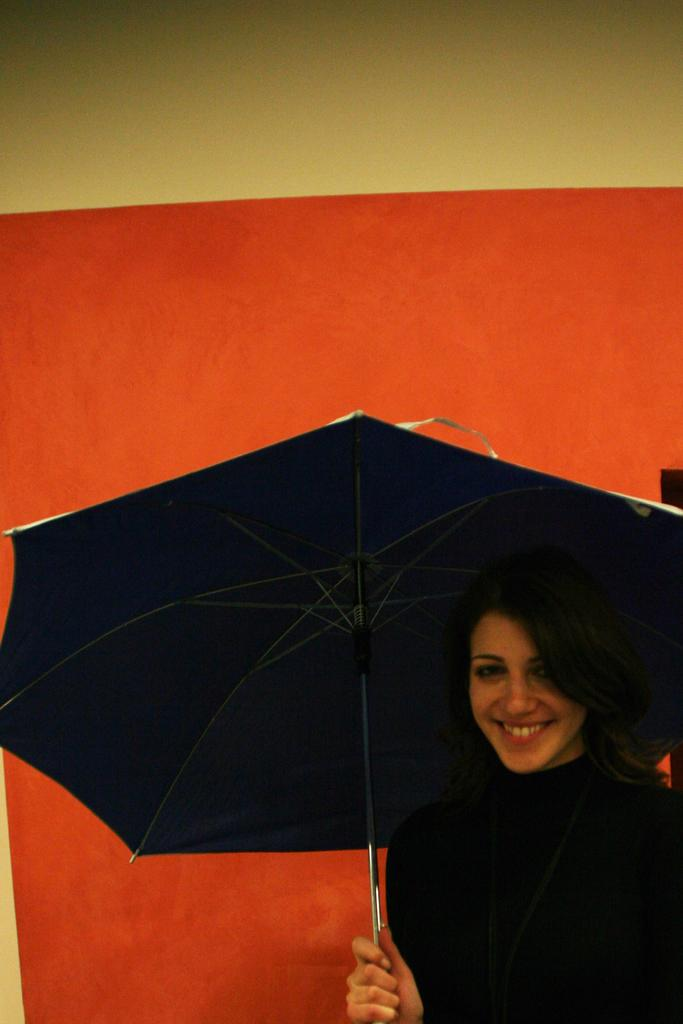Who is present in the image? There is a woman in the image. What is the woman holding in her hand? The woman is holding an umbrella in her hand. What is the woman's facial expression? The woman is smiling. What can be seen in the background of the image? There is a wall visible in the background of the image. What type of dress is the woman wearing in the image? The provided facts do not mention the type of dress the woman is wearing, so we cannot determine that information from the image. 